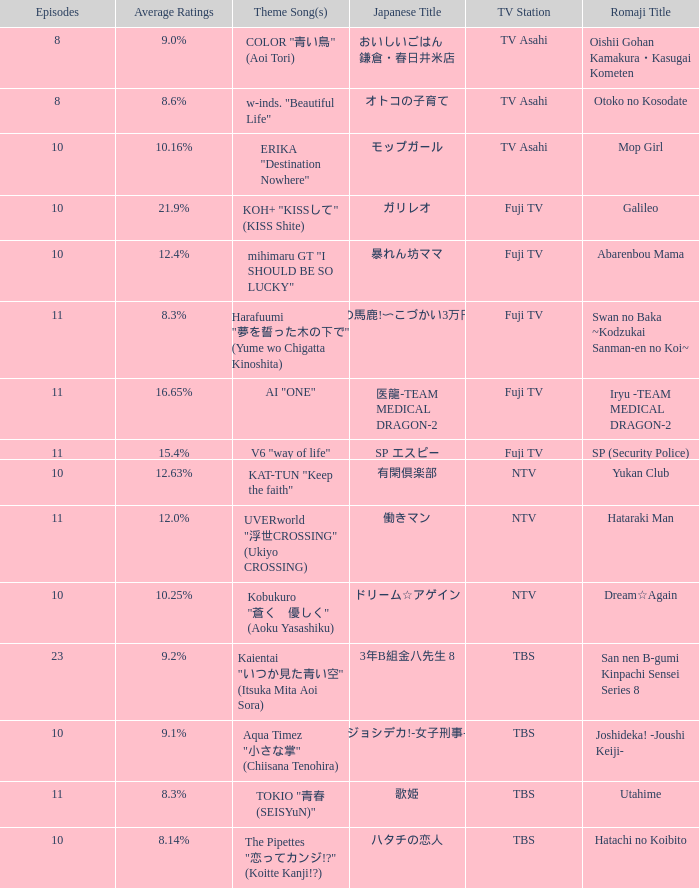What is the yukan club's theme song? KAT-TUN "Keep the faith". 